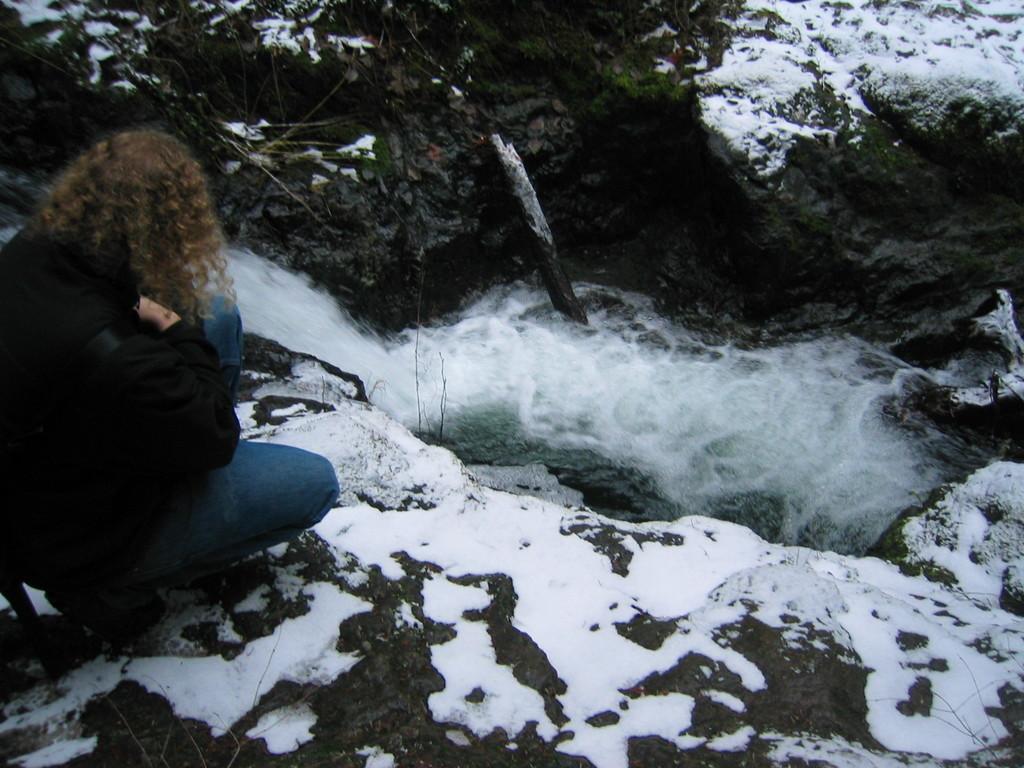In one or two sentences, can you explain what this image depicts? In the picture I can see a person wearing black color jacket is on the left side of the image. Here I can see the snow on the rocks, I can see the waterfall and plants here. 